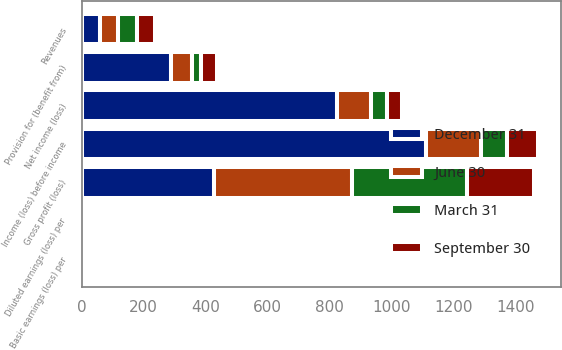Convert chart to OTSL. <chart><loc_0><loc_0><loc_500><loc_500><stacked_bar_chart><ecel><fcel>Revenues<fcel>Gross profit (loss)<fcel>Income (loss) before income<fcel>Provision for (benefit from)<fcel>Net income (loss)<fcel>Basic earnings (loss) per<fcel>Diluted earnings (loss) per<nl><fcel>September 30<fcel>59.45<fcel>216.5<fcel>100.2<fcel>50.1<fcel>50.1<fcel>0.16<fcel>0.16<nl><fcel>December 31<fcel>59.45<fcel>428.3<fcel>1111.4<fcel>287.6<fcel>823.8<fcel>2.62<fcel>2.62<nl><fcel>March 31<fcel>59.45<fcel>371.5<fcel>83.4<fcel>31.7<fcel>51.7<fcel>0.16<fcel>0.16<nl><fcel>June 30<fcel>59.45<fcel>444<fcel>176.9<fcel>67.2<fcel>109.7<fcel>0.35<fcel>0.35<nl></chart> 